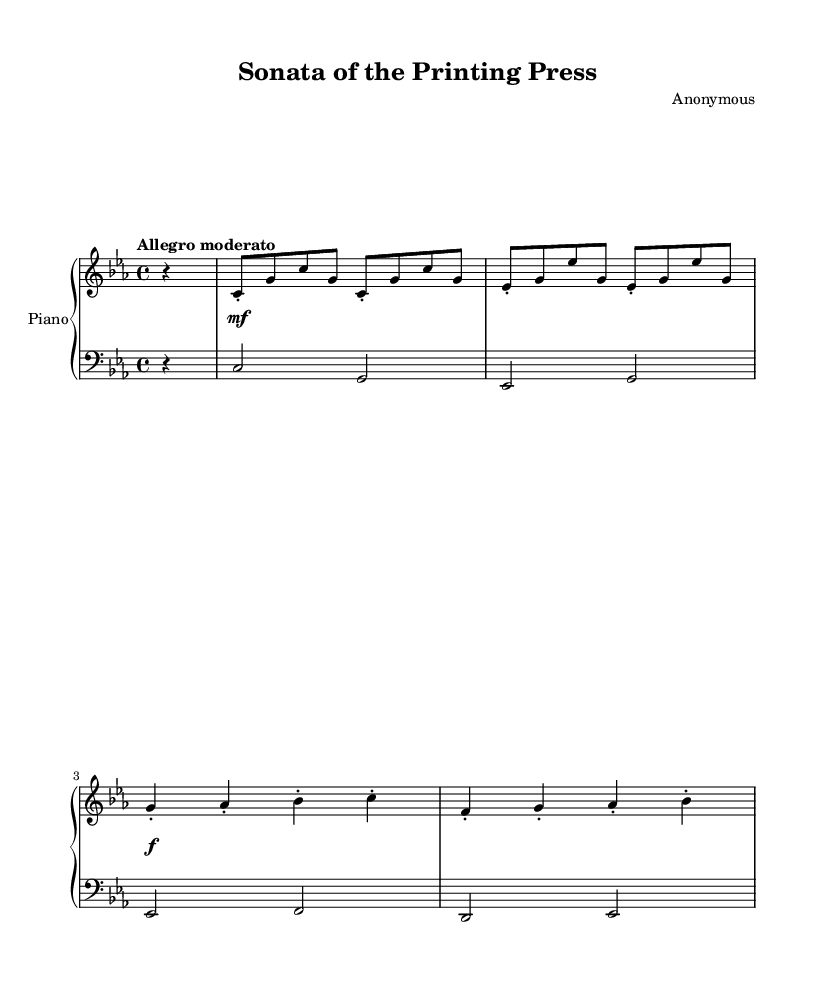What is the key signature of this music? The key signature is C minor, which has three flats (B flat, E flat, and A flat). The key signature is noted at the beginning of the staff, confirming the tonality of the piece.
Answer: C minor What is the time signature of this sonata? The time signature is 4/4, indicated at the beginning of the staff. This means there are four beats per measure, and each quarter note gets one beat.
Answer: 4/4 What is the tempo marking of this piece? The tempo marking is "Allegro moderato," which indicates a moderate and lively tempo. This marking is noted at the beginning of the music, guiding the performer on the intended speed.
Answer: Allegro moderato How many measures are in the right hand of the piece? There are a total of 8 measures in the right hand part, counting each line and space marked for the right hand in the score.
Answer: 8 In which clef is the left hand written? The left hand is written in the bass clef. This is indicated at the beginning of the left hand staff, which signifies lower pitches.
Answer: Bass clef What kind of dynamics are indicated in this music? The dynamics include a range from mezzo-forte (mf) to forte (f), as indicated over the measures in the dynamics part. This shows the expected volume changes throughout the piece.
Answer: mf, f What rhythmic motif is reminiscent of a printing press in this sonata? The rhythmic motif utilizes staccato notes that have a percussive quality, akin to the mechanical sounds of a printing press operating. This is noticeable in the right hand's repeated motifs.
Answer: Staccato 